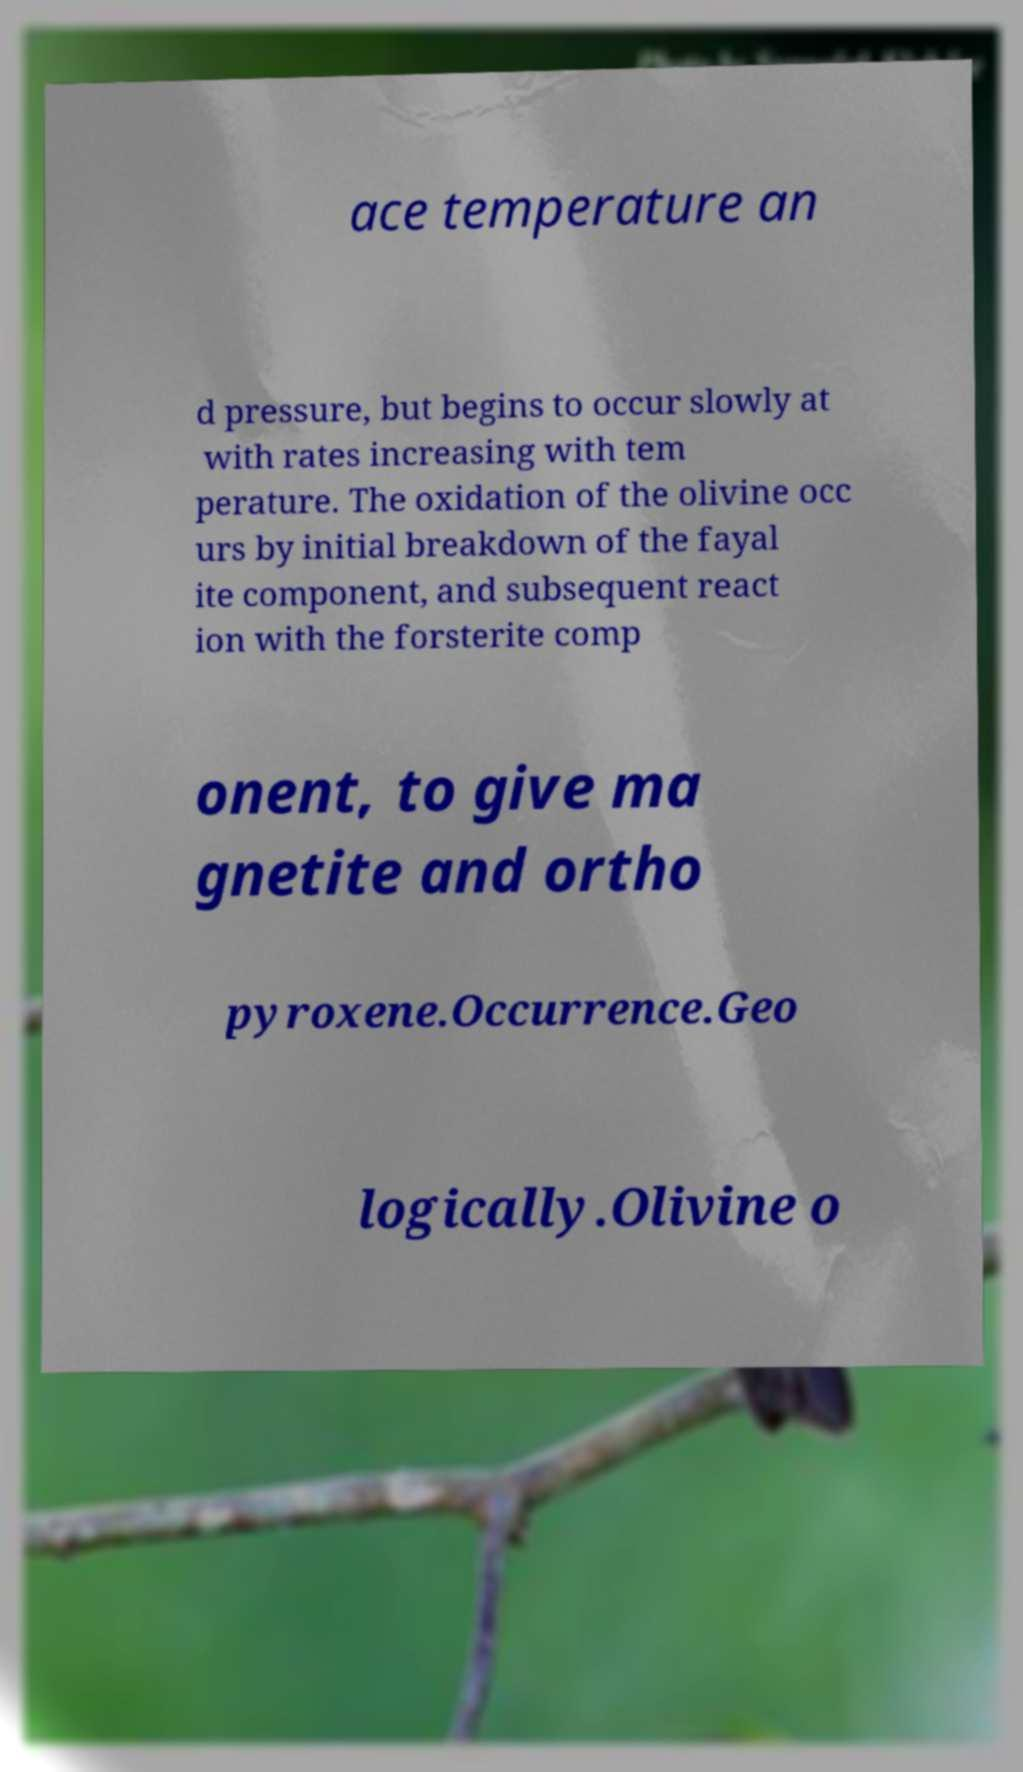I need the written content from this picture converted into text. Can you do that? ace temperature an d pressure, but begins to occur slowly at with rates increasing with tem perature. The oxidation of the olivine occ urs by initial breakdown of the fayal ite component, and subsequent react ion with the forsterite comp onent, to give ma gnetite and ortho pyroxene.Occurrence.Geo logically.Olivine o 